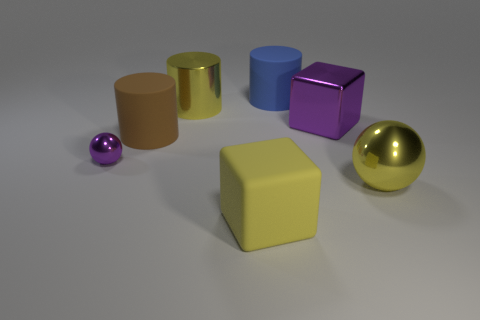Add 2 matte cylinders. How many objects exist? 9 Subtract all blue cylinders. How many cylinders are left? 2 Subtract all balls. How many objects are left? 5 Subtract all large shiny things. Subtract all large metal objects. How many objects are left? 1 Add 5 large yellow shiny things. How many large yellow shiny things are left? 7 Add 6 blue matte cylinders. How many blue matte cylinders exist? 7 Subtract 0 cyan cylinders. How many objects are left? 7 Subtract all purple cylinders. Subtract all red blocks. How many cylinders are left? 3 